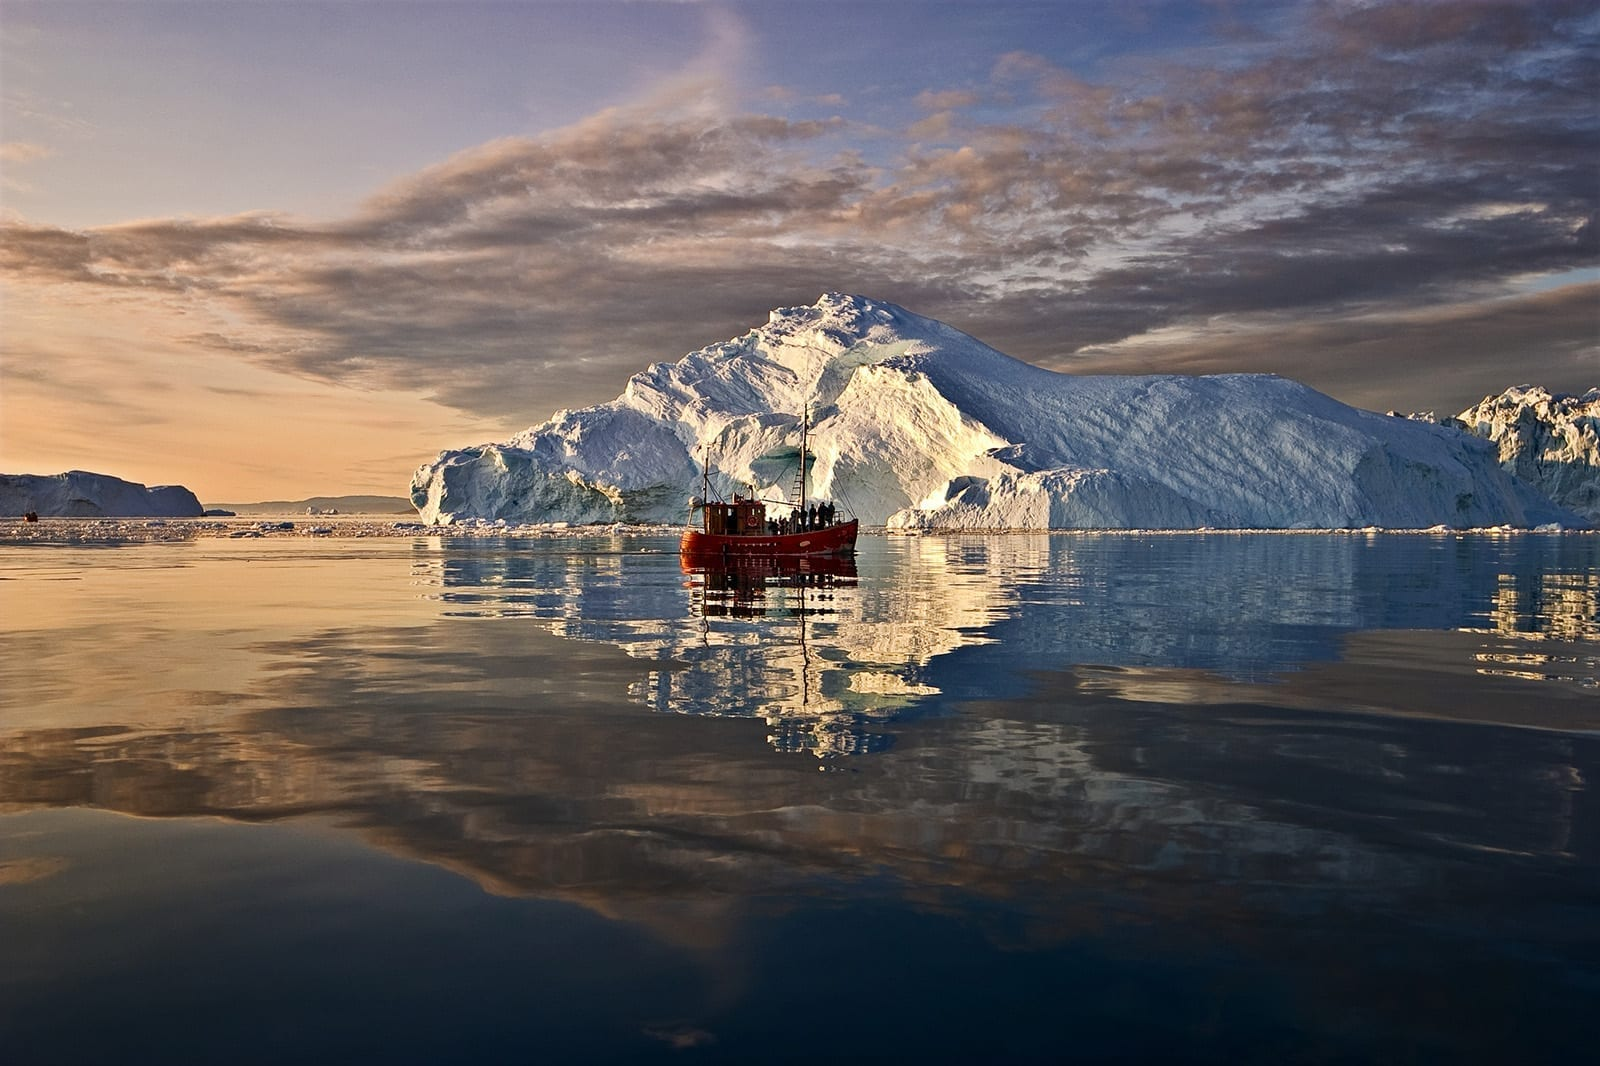Can you tell me more about the significance of the red boat in this image? Certainly! The red boat in the image serves as a vibrant focal point amidst the grand icebergs. It likely represents the human element in this wild, natural setting. Boats like this are often used for scientific research or to take tourists on trips to witness the beauty of the Icefjord up close. The size of the boat compared to the icebergs underscores the immense scale and the raw power of nature present in this environment. 